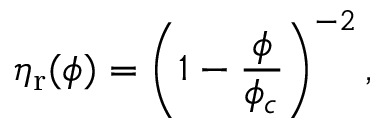<formula> <loc_0><loc_0><loc_500><loc_500>\eta _ { r } ( \phi ) = \left ( 1 - \frac { \phi } { \phi _ { c } } \right ) ^ { - 2 } ,</formula> 